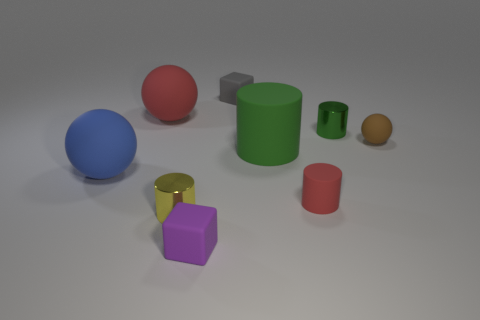There is a rubber cube that is the same size as the gray object; what color is it?
Give a very brief answer. Purple. How many other things are there of the same shape as the tiny yellow metal thing?
Your answer should be very brief. 3. There is a green rubber object; does it have the same size as the red matte object left of the big green cylinder?
Provide a succinct answer. Yes. What number of things are either large green metal cubes or cylinders?
Offer a very short reply. 4. How many other things are the same size as the blue rubber thing?
Provide a short and direct response. 2. Do the big matte cylinder and the metal object that is on the right side of the gray rubber block have the same color?
Your answer should be compact. Yes. How many cylinders are tiny blue shiny objects or small green objects?
Keep it short and to the point. 1. Is there anything else that has the same color as the large cylinder?
Your answer should be very brief. Yes. What material is the big sphere to the left of the large matte ball behind the blue matte thing made of?
Ensure brevity in your answer.  Rubber. Does the small brown object have the same material as the small thing on the left side of the tiny purple object?
Your response must be concise. No. 